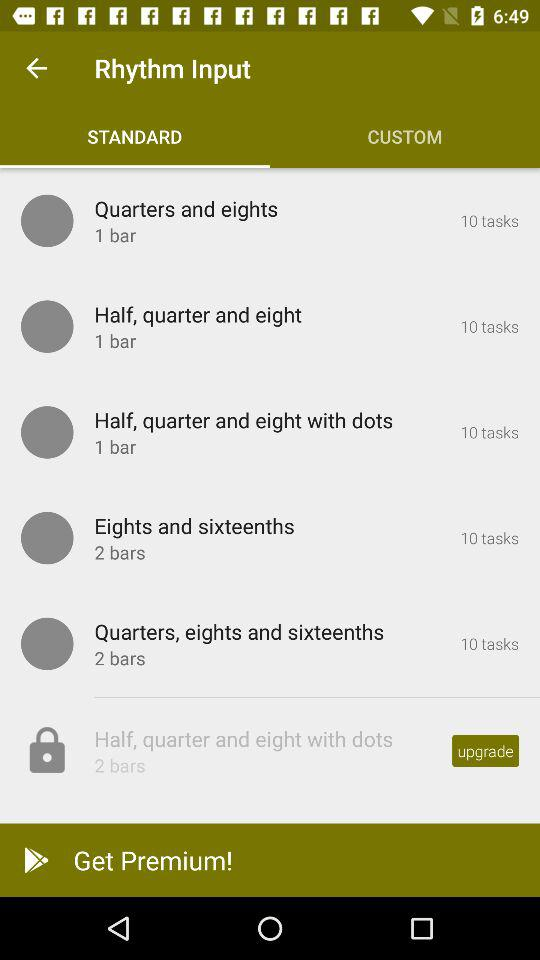How many tasks are there in "Quarters and eights"? There are 10 tasks. 